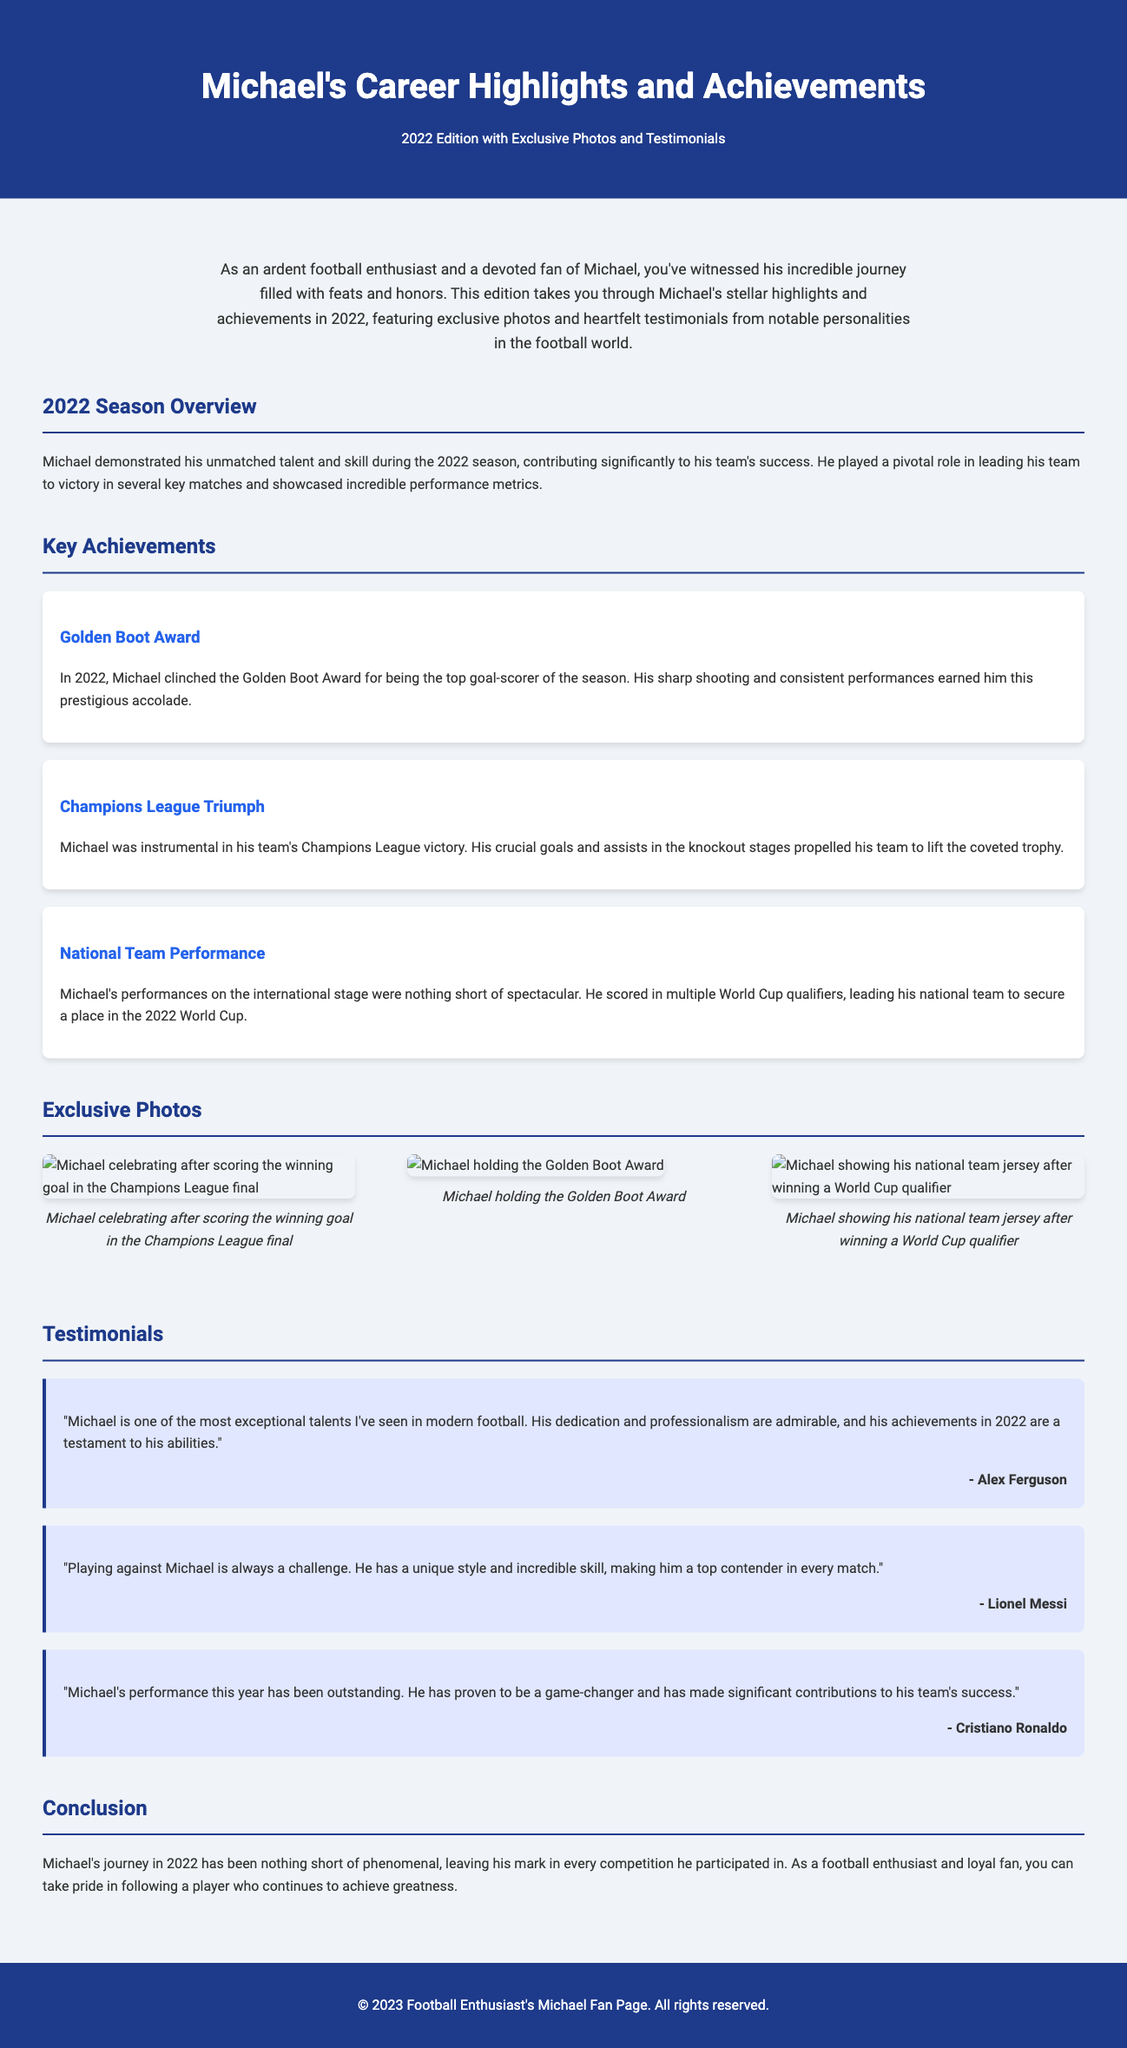What award did Michael win in 2022? The document states that Michael won the Golden Boot Award for being the top goal-scorer of the season.
Answer: Golden Boot Award What trophy did Michael's team lift in 2022? It mentions that Michael was instrumental in his team's Champions League victory, where they lifted the trophy.
Answer: Champions League How many key achievements are highlighted in the document? The document lists three key achievements related to Michael's career in 2022.
Answer: Three Who provided a testimonial about Michael's dedication? Alex Ferguson is noted for praising Michael's dedication and professionalism in the testimonials section.
Answer: Alex Ferguson What significant international event did Michael help his team qualify for? The document indicates that Michael led his national team to secure a place in the 2022 World Cup through qualifiers.
Answer: 2022 World Cup Which player described playing against Michael as a challenge? Lionel Messi mentioned that playing against Michael is a challenge due to his unique style and skill.
Answer: Lionel Messi How many exclusive photos are featured in the document? The document features three exclusive photos showcasing Michael's highlights in 2022.
Answer: Three What was the color of the header background in the document? The header background color is specified as dark blue (#1e3a8a) in the document styles.
Answer: Dark blue What is the primary focus of the document? The document primarily focuses on Michael's career highlights and achievements in 2022.
Answer: Career highlights and achievements 